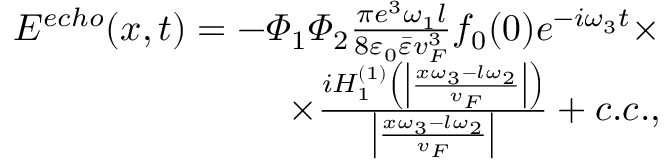<formula> <loc_0><loc_0><loc_500><loc_500>\begin{array} { r } { E ^ { e c h o } ( x , t ) = - \varPhi _ { 1 } \varPhi _ { 2 } \frac { \pi e ^ { 3 } \omega _ { 1 } l } { 8 \varepsilon _ { 0 } \bar { \varepsilon } v _ { F } ^ { 3 } } f _ { 0 } ( 0 ) e ^ { - i \omega _ { 3 } t } \times } \\ { \times \frac { i H _ { 1 } ^ { ( 1 ) } \left ( \left | \frac { x \omega _ { 3 } - l \omega _ { 2 } } { v _ { F } } \right | \right ) } { \left | \frac { x \omega _ { 3 } - l \omega _ { 2 } } { v _ { F } } \right | } + c . c . , } \end{array}</formula> 